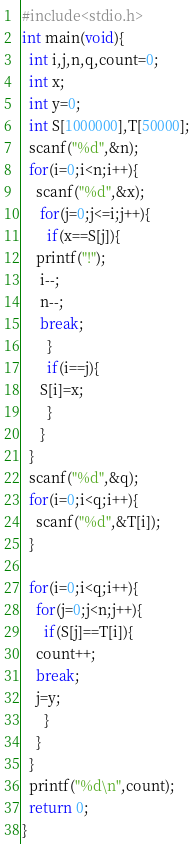<code> <loc_0><loc_0><loc_500><loc_500><_C_>#include<stdio.h>
int main(void){
  int i,j,n,q,count=0;
  int x;
  int y=0;
  int S[1000000],T[50000];
  scanf("%d",&n);
  for(i=0;i<n;i++){
 	scanf("%d",&x);
     for(j=0;j<=i;j++){
       if(x==S[j]){
	printf("!");
	 i--;
	 n--;
	 break;
       }
       if(i==j){
	 S[i]=x;
       }
     }
  }
  scanf("%d",&q);
  for(i=0;i<q;i++){
    scanf("%d",&T[i]);
  }

  for(i=0;i<q;i++){
    for(j=0;j<n;j++){
      if(S[j]==T[i]){
	count++;
	break;
	j=y;
      }
    }
  }
  printf("%d\n",count);
  return 0;
}</code> 